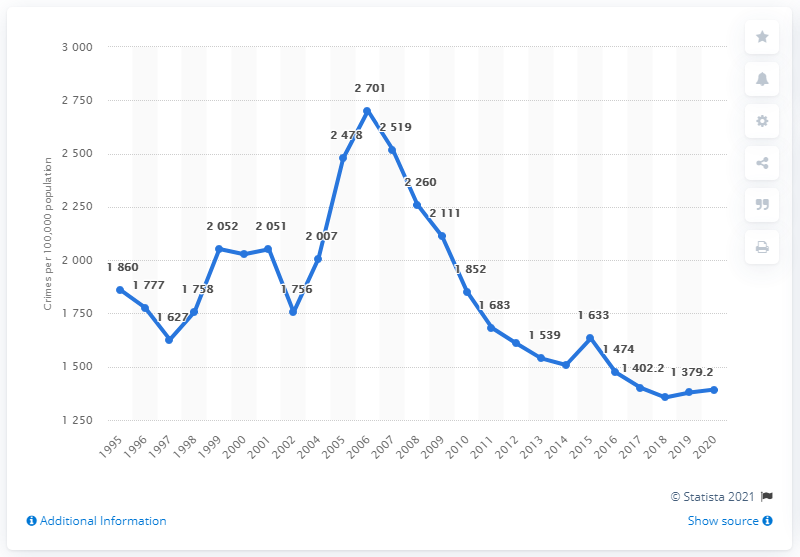Draw attention to some important aspects in this diagram. According to data from 2020, the crime rate in Russia was 1393. 